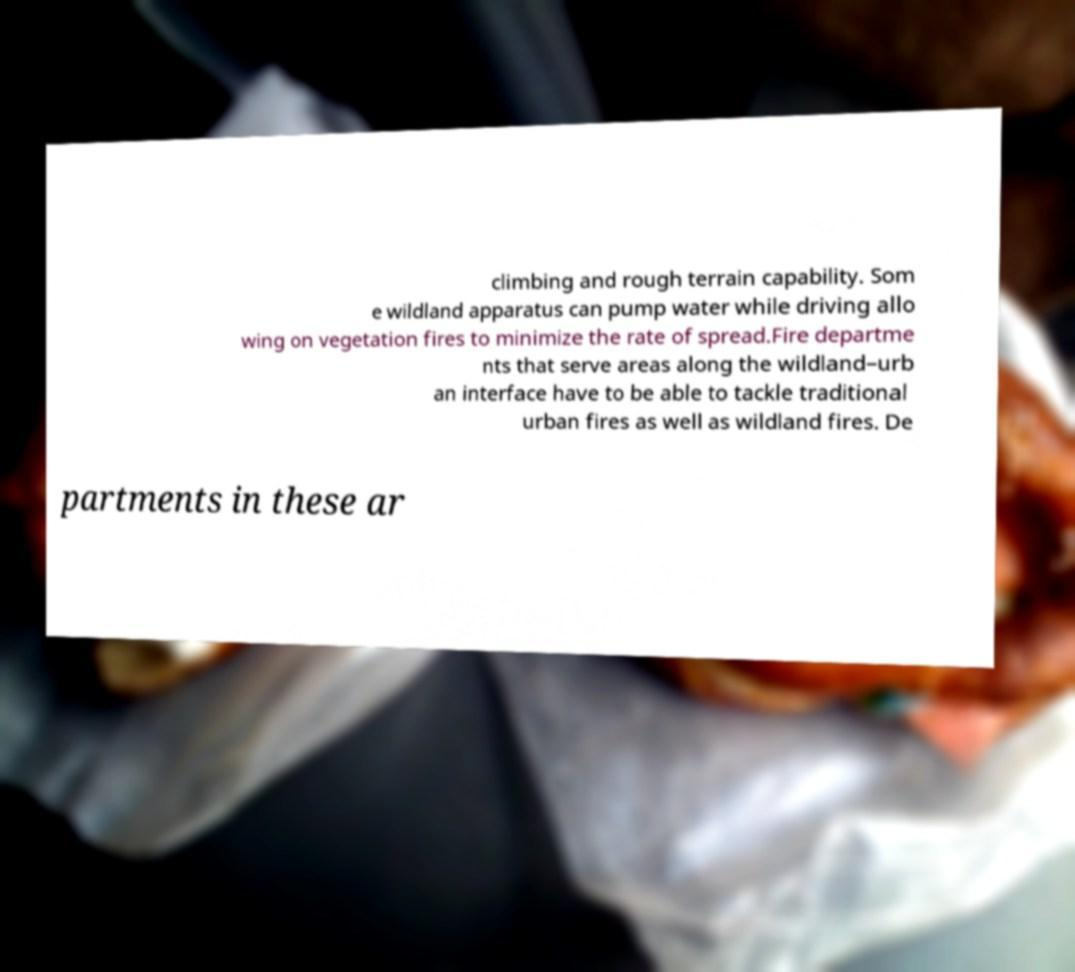Could you assist in decoding the text presented in this image and type it out clearly? climbing and rough terrain capability. Som e wildland apparatus can pump water while driving allo wing on vegetation fires to minimize the rate of spread.Fire departme nts that serve areas along the wildland–urb an interface have to be able to tackle traditional urban fires as well as wildland fires. De partments in these ar 